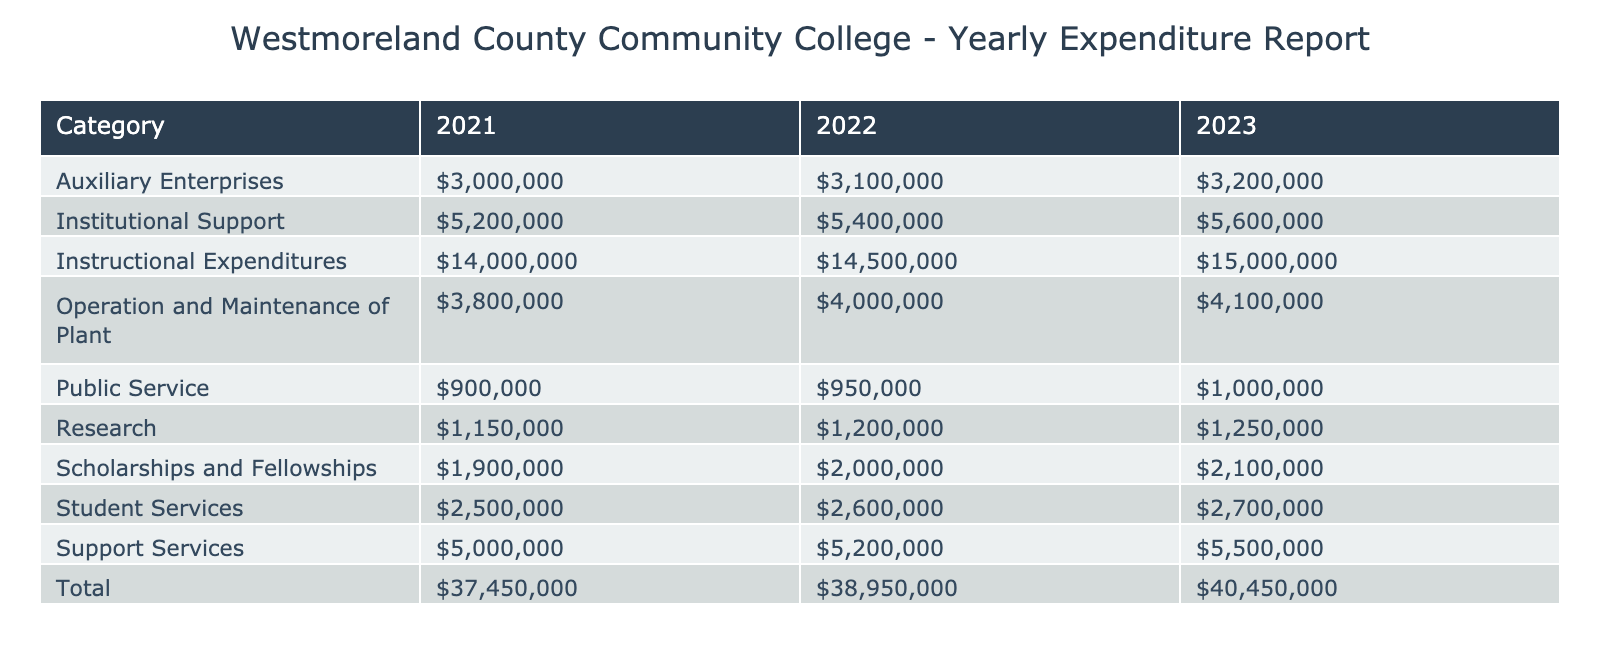What is the total amount spent on Instructional Expenditures in 2022? Looking at the table, the amount listed for Instructional Expenditures in 2022 is $14,500,000.
Answer: $14,500,000 Which category received the highest expenditure across all three years? By comparing the amounts in each category across the years, Instructional Expenditures has the highest total amount of $14,000,000 (2021) + $14,500,000 (2022) + $15,000,000 (2023) = $43,500,000.
Answer: Instructional Expenditures What is the average amount spent on Student Services over the three years? The amounts for Student Services are $2,500,000 (2021), $2,600,000 (2022), and $2,700,000 (2023). Adding these gives $2,500,000 + $2,600,000 + $2,700,000 = $7,800,000. Dividing by 3 results in an average of $7,800,000 / 3 = $2,600,000.
Answer: $2,600,000 Did the total amount spent on Public Service increase every year from 2021 to 2023? From the table, the amounts spent on Public Service are $900,000 in 2021, $950,000 in 2022, and $1,000,000 in 2023. Since each of these amounts is higher than the previous year, the expenditure increased every year.
Answer: Yes What was the change in total expenditure for Auxiliary Enterprises from 2021 to 2023? Auxiliary Enterprises had expenditures of $3,000,000 in 2021 and $3,200,000 in 2023. The change can be calculated as $3,200,000 - $3,000,000 = $200,000, indicating an increase.
Answer: $200,000 increase What is the total expenditure on Support Services across all years? The expenditures for Support Services are $5,000,000 (2021) + $5,200,000 (2022) + $5,500,000 (2023), which totals to $5,000,000 + $5,200,000 + $5,500,000 = $15,700,000.
Answer: $15,700,000 Was the expenditure on Scholarships and Fellowships higher in 2023 compared to 2021? The amounts listed are $1,900,000 for 2021 and $2,100,000 for 2023. Since $2,100,000 is greater than $1,900,000, the expenditure was higher in 2023.
Answer: Yes How much more was spent on Operation and Maintenance of Plant in 2023 compared to 2021? The expenditure for Operation and Maintenance of Plant in 2021 was $3,800,000, while in 2023 it was $4,100,000. The difference is calculated as $4,100,000 - $3,800,000 = $300,000.
Answer: $300,000 more What is the total amount spent on Research over three years? The amounts for Research are $1,150,000 (2021), $1,200,000 (2022), and $1,250,000 (2023). Totaling these gives $1,150,000 + $1,200,000 + $1,250,000 = $3,600,000.
Answer: $3,600,000 